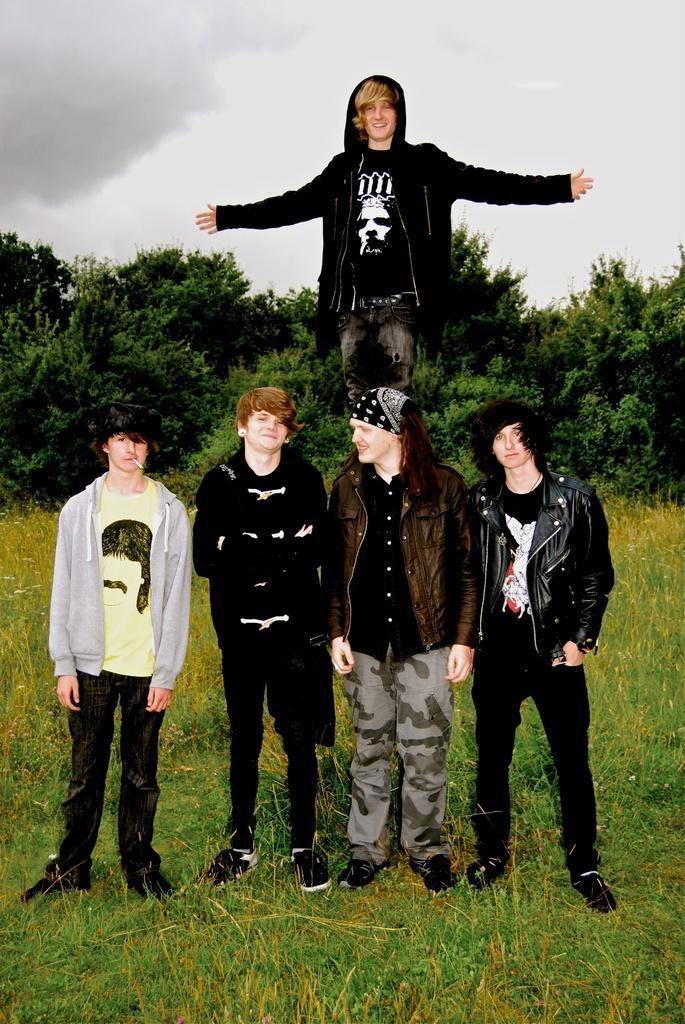Can you describe this image briefly? This picture is clicked outside. In the center we can see the group of persons standing on the ground. The ground is covered with the grass and we can see a person seems to be standing on an object. In the background we can see the trees, plants and the sky. 